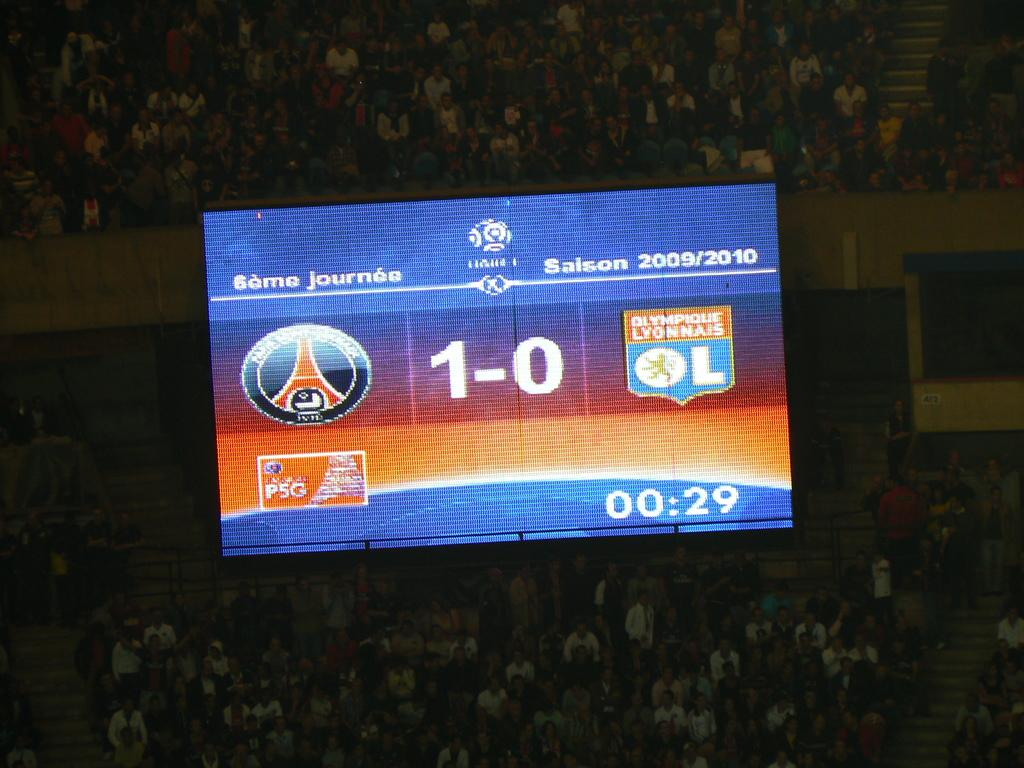<image>
Describe the image concisely. A screen above a crowd that says Game Journee and a score of 1 to 0 on it. 